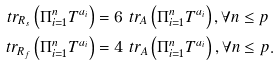Convert formula to latex. <formula><loc_0><loc_0><loc_500><loc_500>\ t r _ { R _ { s } } \left ( \Pi _ { i = 1 } ^ { n } T ^ { a _ { i } } \right ) & = 6 \ t r _ { A } \left ( \Pi _ { i = 1 } ^ { n } T ^ { a _ { i } } \right ) , \forall n \leq p \\ \ t r _ { R _ { f } } \left ( \Pi _ { i = 1 } ^ { n } T ^ { a _ { i } } \right ) & = 4 \ t r _ { A } \left ( \Pi _ { i = 1 } ^ { n } T ^ { a _ { i } } \right ) , \forall n \leq p .</formula> 